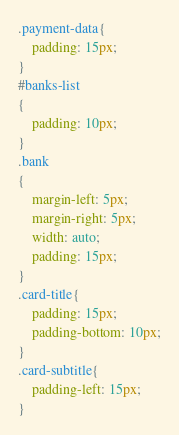Convert code to text. <code><loc_0><loc_0><loc_500><loc_500><_CSS_>.payment-data{
    padding: 15px;
}
#banks-list
{
    padding: 10px;
}
.bank
{
    margin-left: 5px;
    margin-right: 5px;
    width: auto;
    padding: 15px;
}
.card-title{
    padding: 15px;
    padding-bottom: 10px;
}
.card-subtitle{
    padding-left: 15px;
}
</code> 